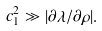<formula> <loc_0><loc_0><loc_500><loc_500>c _ { 1 } ^ { 2 } \gg | \partial \lambda / \partial \rho | .</formula> 